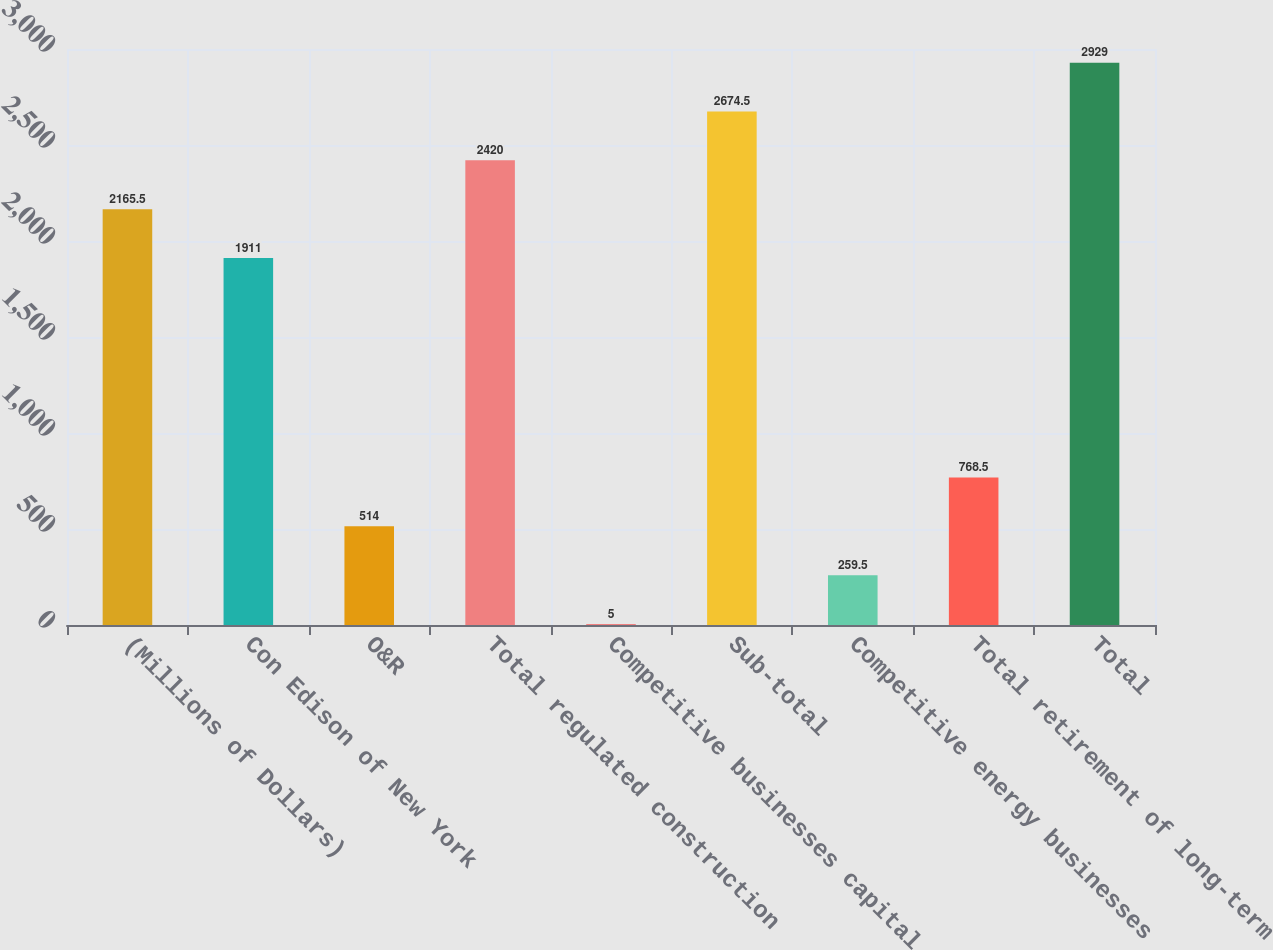Convert chart. <chart><loc_0><loc_0><loc_500><loc_500><bar_chart><fcel>(Millions of Dollars)<fcel>Con Edison of New York<fcel>O&R<fcel>Total regulated construction<fcel>Competitive businesses capital<fcel>Sub-total<fcel>Competitive energy businesses<fcel>Total retirement of long-term<fcel>Total<nl><fcel>2165.5<fcel>1911<fcel>514<fcel>2420<fcel>5<fcel>2674.5<fcel>259.5<fcel>768.5<fcel>2929<nl></chart> 